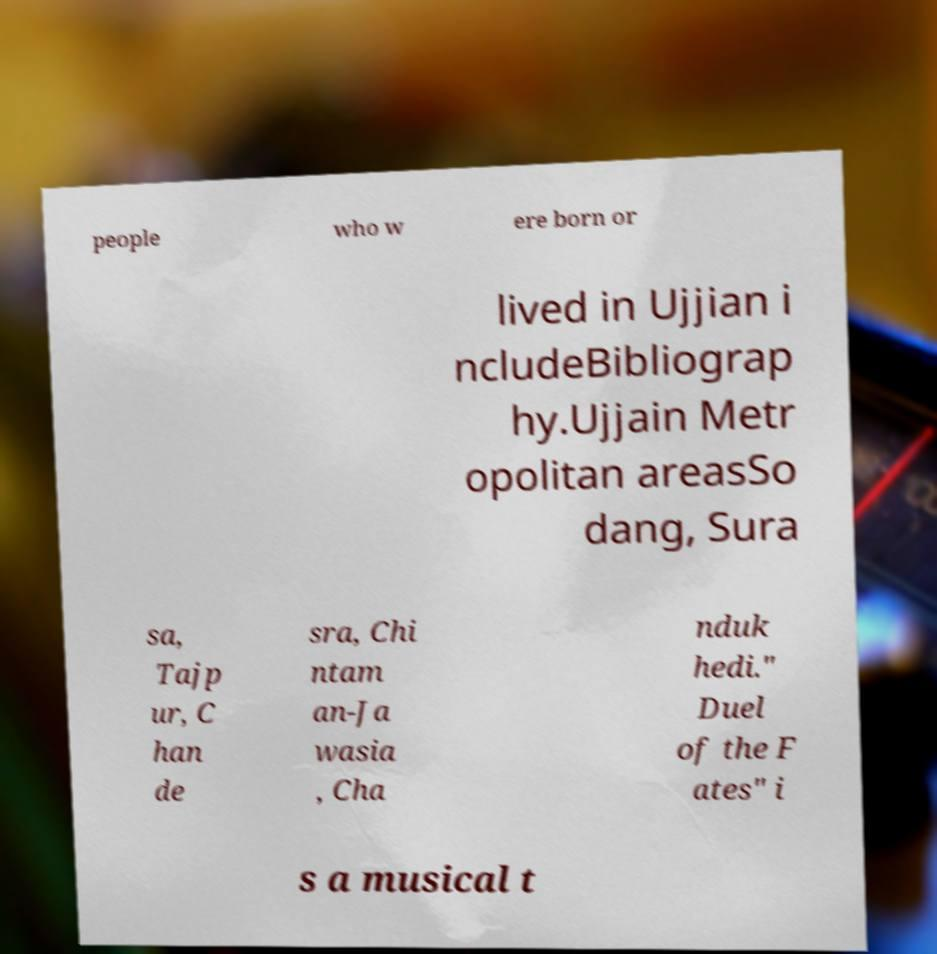Please identify and transcribe the text found in this image. people who w ere born or lived in Ujjian i ncludeBibliograp hy.Ujjain Metr opolitan areasSo dang, Sura sa, Tajp ur, C han de sra, Chi ntam an-Ja wasia , Cha nduk hedi." Duel of the F ates" i s a musical t 